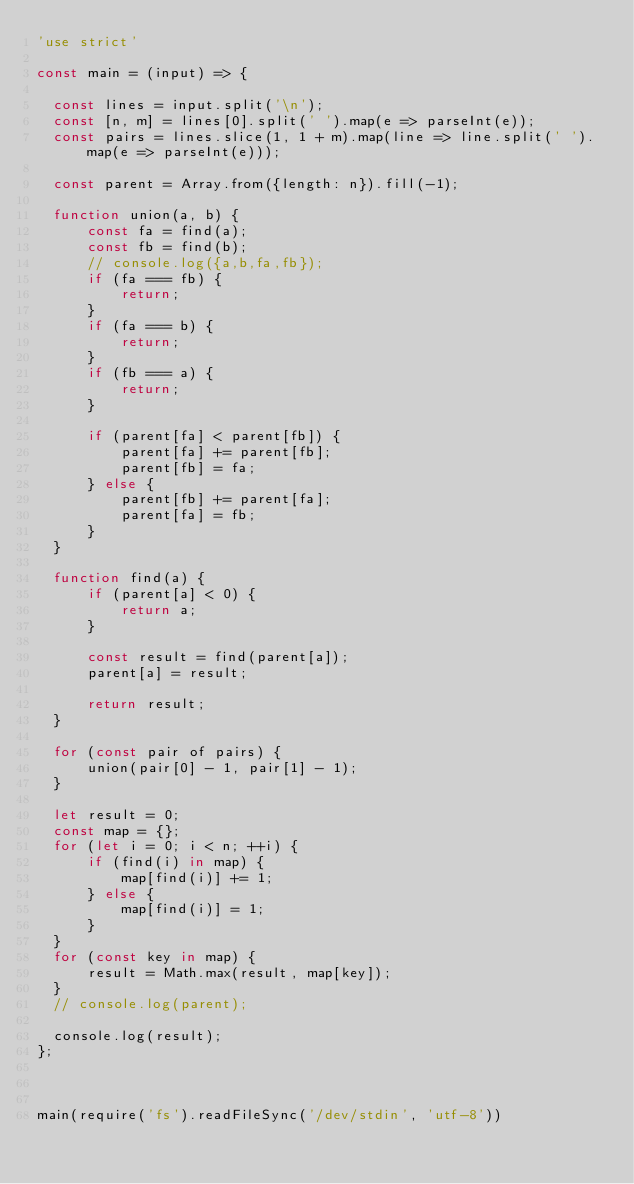Convert code to text. <code><loc_0><loc_0><loc_500><loc_500><_JavaScript_>'use strict'

const main = (input) => {

  const lines = input.split('\n');
  const [n, m] = lines[0].split(' ').map(e => parseInt(e));
  const pairs = lines.slice(1, 1 + m).map(line => line.split(' ').map(e => parseInt(e)));
  
  const parent = Array.from({length: n}).fill(-1);
  
  function union(a, b) {
      const fa = find(a);
      const fb = find(b);
      // console.log({a,b,fa,fb});
      if (fa === fb) {
          return;
      }
      if (fa === b) {
          return;
      }
      if (fb === a) {
          return;
      }
      
      if (parent[fa] < parent[fb]) {
          parent[fa] += parent[fb];
          parent[fb] = fa;
      } else {
          parent[fb] += parent[fa];
          parent[fa] = fb;
      }
  }
  
  function find(a) {
      if (parent[a] < 0) {
          return a;
      }
      
      const result = find(parent[a]);
      parent[a] = result;
      
      return result;
  }

  for (const pair of pairs) {
      union(pair[0] - 1, pair[1] - 1);
  }

  let result = 0;
  const map = {};
  for (let i = 0; i < n; ++i) {
      if (find(i) in map) {
          map[find(i)] += 1;
      } else {
          map[find(i)] = 1;
      }
  }
  for (const key in map) {
      result = Math.max(result, map[key]);
  }
  // console.log(parent);
  
  console.log(result);
};



main(require('fs').readFileSync('/dev/stdin', 'utf-8'))</code> 